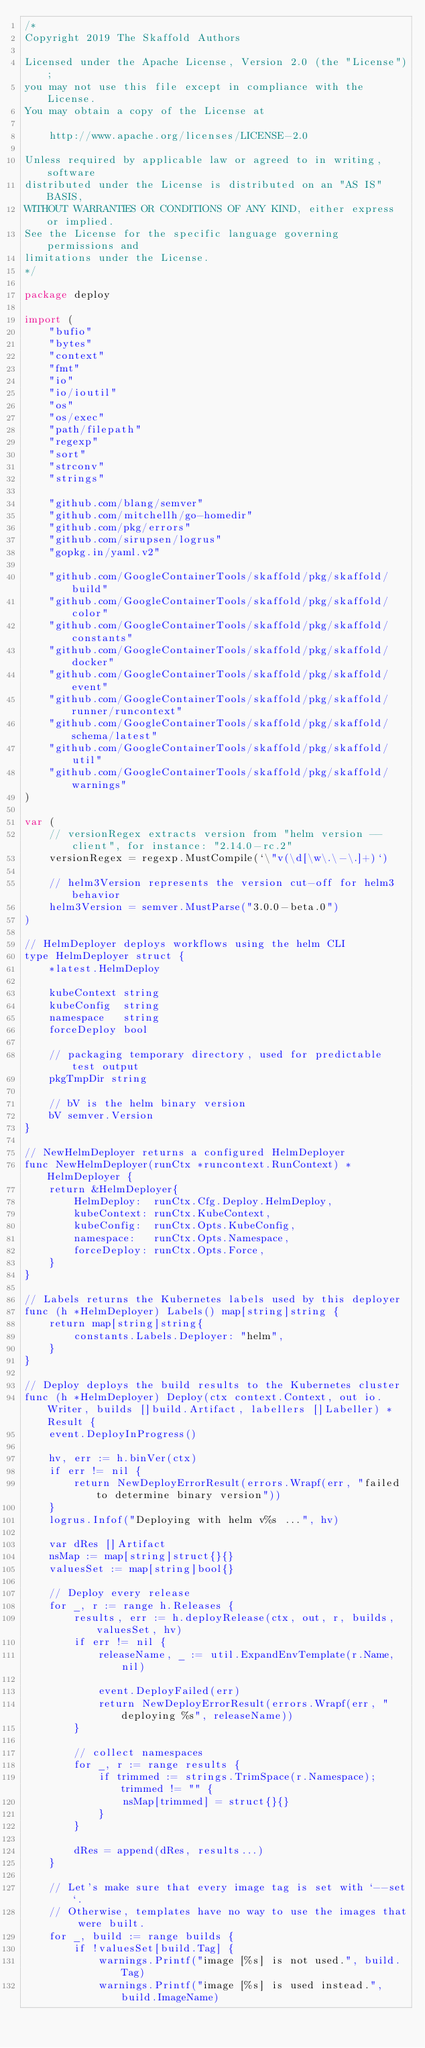Convert code to text. <code><loc_0><loc_0><loc_500><loc_500><_Go_>/*
Copyright 2019 The Skaffold Authors

Licensed under the Apache License, Version 2.0 (the "License");
you may not use this file except in compliance with the License.
You may obtain a copy of the License at

    http://www.apache.org/licenses/LICENSE-2.0

Unless required by applicable law or agreed to in writing, software
distributed under the License is distributed on an "AS IS" BASIS,
WITHOUT WARRANTIES OR CONDITIONS OF ANY KIND, either express or implied.
See the License for the specific language governing permissions and
limitations under the License.
*/

package deploy

import (
	"bufio"
	"bytes"
	"context"
	"fmt"
	"io"
	"io/ioutil"
	"os"
	"os/exec"
	"path/filepath"
	"regexp"
	"sort"
	"strconv"
	"strings"

	"github.com/blang/semver"
	"github.com/mitchellh/go-homedir"
	"github.com/pkg/errors"
	"github.com/sirupsen/logrus"
	"gopkg.in/yaml.v2"

	"github.com/GoogleContainerTools/skaffold/pkg/skaffold/build"
	"github.com/GoogleContainerTools/skaffold/pkg/skaffold/color"
	"github.com/GoogleContainerTools/skaffold/pkg/skaffold/constants"
	"github.com/GoogleContainerTools/skaffold/pkg/skaffold/docker"
	"github.com/GoogleContainerTools/skaffold/pkg/skaffold/event"
	"github.com/GoogleContainerTools/skaffold/pkg/skaffold/runner/runcontext"
	"github.com/GoogleContainerTools/skaffold/pkg/skaffold/schema/latest"
	"github.com/GoogleContainerTools/skaffold/pkg/skaffold/util"
	"github.com/GoogleContainerTools/skaffold/pkg/skaffold/warnings"
)

var (
	// versionRegex extracts version from "helm version --client", for instance: "2.14.0-rc.2"
	versionRegex = regexp.MustCompile(`\"v(\d[\w\.\-\.]+)`)

	// helm3Version represents the version cut-off for helm3 behavior
	helm3Version = semver.MustParse("3.0.0-beta.0")
)

// HelmDeployer deploys workflows using the helm CLI
type HelmDeployer struct {
	*latest.HelmDeploy

	kubeContext string
	kubeConfig  string
	namespace   string
	forceDeploy bool

	// packaging temporary directory, used for predictable test output
	pkgTmpDir string

	// bV is the helm binary version
	bV semver.Version
}

// NewHelmDeployer returns a configured HelmDeployer
func NewHelmDeployer(runCtx *runcontext.RunContext) *HelmDeployer {
	return &HelmDeployer{
		HelmDeploy:  runCtx.Cfg.Deploy.HelmDeploy,
		kubeContext: runCtx.KubeContext,
		kubeConfig:  runCtx.Opts.KubeConfig,
		namespace:   runCtx.Opts.Namespace,
		forceDeploy: runCtx.Opts.Force,
	}
}

// Labels returns the Kubernetes labels used by this deployer
func (h *HelmDeployer) Labels() map[string]string {
	return map[string]string{
		constants.Labels.Deployer: "helm",
	}
}

// Deploy deploys the build results to the Kubernetes cluster
func (h *HelmDeployer) Deploy(ctx context.Context, out io.Writer, builds []build.Artifact, labellers []Labeller) *Result {
	event.DeployInProgress()

	hv, err := h.binVer(ctx)
	if err != nil {
		return NewDeployErrorResult(errors.Wrapf(err, "failed to determine binary version"))
	}
	logrus.Infof("Deploying with helm v%s ...", hv)

	var dRes []Artifact
	nsMap := map[string]struct{}{}
	valuesSet := map[string]bool{}

	// Deploy every release
	for _, r := range h.Releases {
		results, err := h.deployRelease(ctx, out, r, builds, valuesSet, hv)
		if err != nil {
			releaseName, _ := util.ExpandEnvTemplate(r.Name, nil)

			event.DeployFailed(err)
			return NewDeployErrorResult(errors.Wrapf(err, "deploying %s", releaseName))
		}

		// collect namespaces
		for _, r := range results {
			if trimmed := strings.TrimSpace(r.Namespace); trimmed != "" {
				nsMap[trimmed] = struct{}{}
			}
		}

		dRes = append(dRes, results...)
	}

	// Let's make sure that every image tag is set with `--set`.
	// Otherwise, templates have no way to use the images that were built.
	for _, build := range builds {
		if !valuesSet[build.Tag] {
			warnings.Printf("image [%s] is not used.", build.Tag)
			warnings.Printf("image [%s] is used instead.", build.ImageName)</code> 